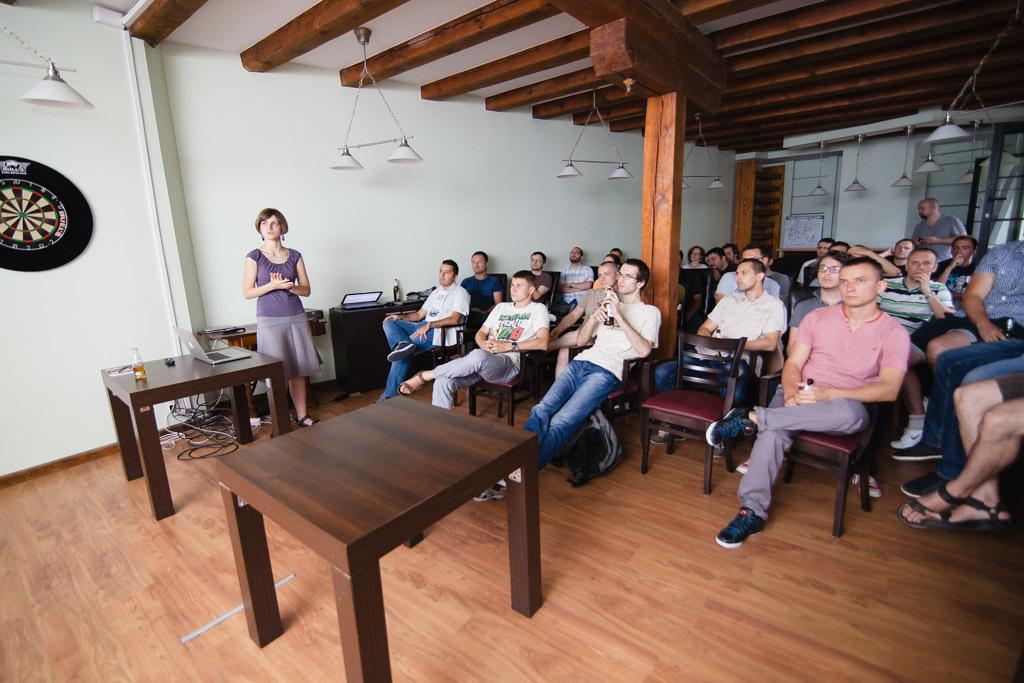What is the main subject of the image? There is a woman standing in the image. What can be seen in the background of the image? There is a table in the image. What is placed on the table? A laptop is present on the right side of the table. What are the people in the image doing? There are people sitting on chairs in the image, and they are looking towards the woman's side. What type of hose is connected to the laptop in the image? There is no hose connected to the laptop in the image. What is the woman's mind thinking about in the image? The image does not provide information about the woman's thoughts or mental state. 